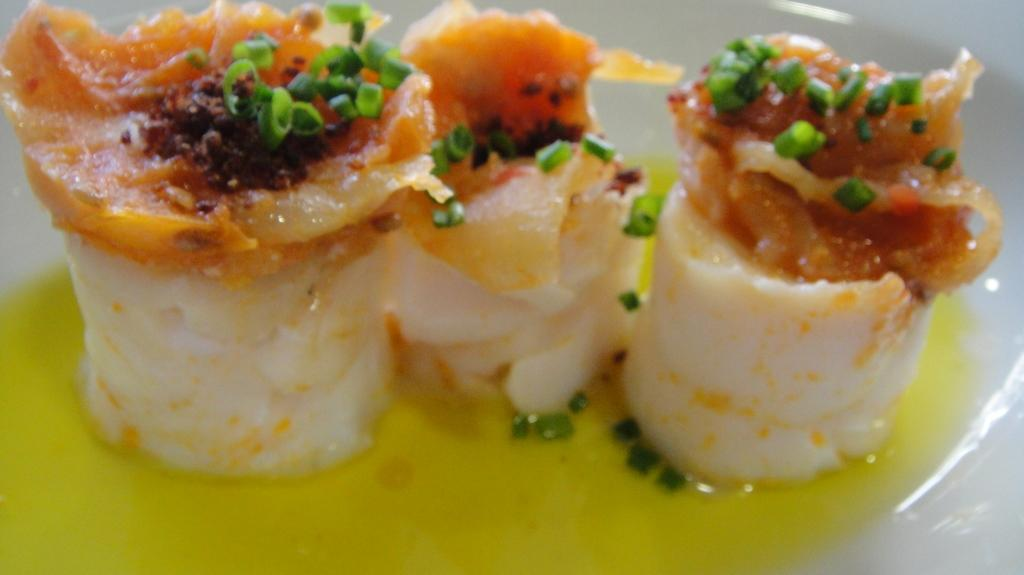What type of food is shown in the image? There are rolls in the image. How are the rolls decorated? The rolls are garnished with orange-colored ingredients. What other food item can be seen on the rolls? There are peas on the rolls. What is the rolls' interaction with another food item? The rolls are dipped in yolk. Where is the deer in the image? There is no deer present in the image. Can you describe the faucet in the image? There is no faucet present in the image. 